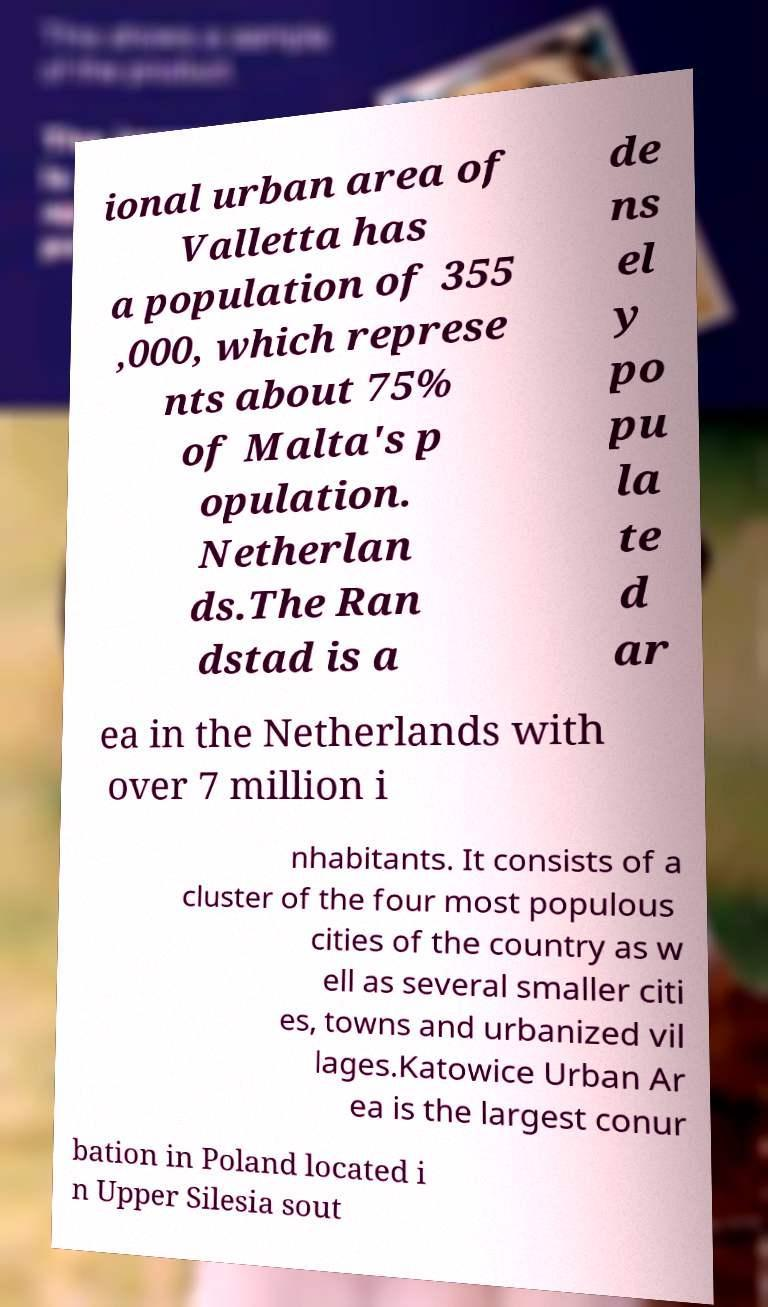Can you accurately transcribe the text from the provided image for me? ional urban area of Valletta has a population of 355 ,000, which represe nts about 75% of Malta's p opulation. Netherlan ds.The Ran dstad is a de ns el y po pu la te d ar ea in the Netherlands with over 7 million i nhabitants. It consists of a cluster of the four most populous cities of the country as w ell as several smaller citi es, towns and urbanized vil lages.Katowice Urban Ar ea is the largest conur bation in Poland located i n Upper Silesia sout 